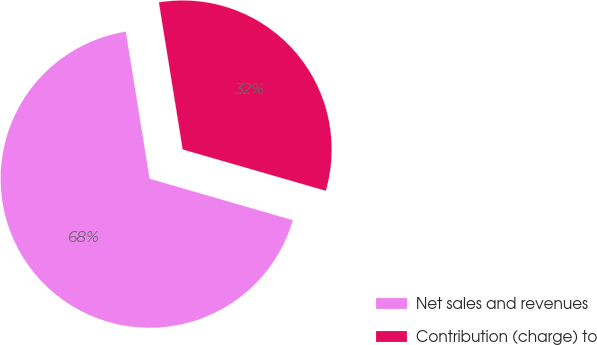Convert chart to OTSL. <chart><loc_0><loc_0><loc_500><loc_500><pie_chart><fcel>Net sales and revenues<fcel>Contribution (charge) to<nl><fcel>67.97%<fcel>32.03%<nl></chart> 